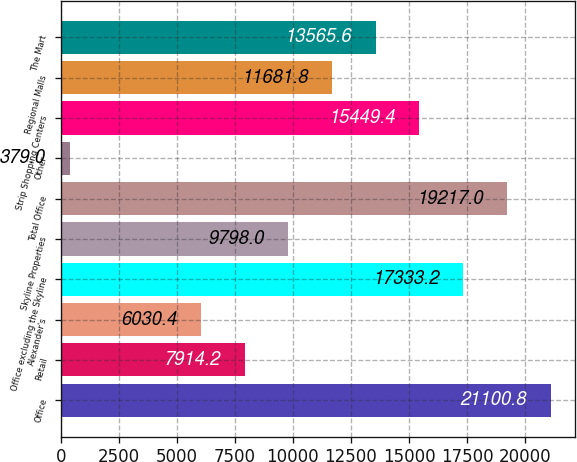<chart> <loc_0><loc_0><loc_500><loc_500><bar_chart><fcel>Office<fcel>Retail<fcel>Alexander's<fcel>Office excluding the Skyline<fcel>Skyline Properties<fcel>Total Office<fcel>Other<fcel>Strip Shopping Centers<fcel>Regional Malls<fcel>The Mart<nl><fcel>21100.8<fcel>7914.2<fcel>6030.4<fcel>17333.2<fcel>9798<fcel>19217<fcel>379<fcel>15449.4<fcel>11681.8<fcel>13565.6<nl></chart> 